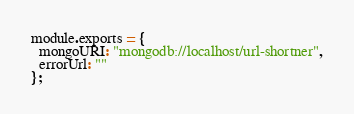Convert code to text. <code><loc_0><loc_0><loc_500><loc_500><_JavaScript_>module.exports = {
  mongoURI: "mongodb://localhost/url-shortner",
  errorUrl: ""
};
</code> 